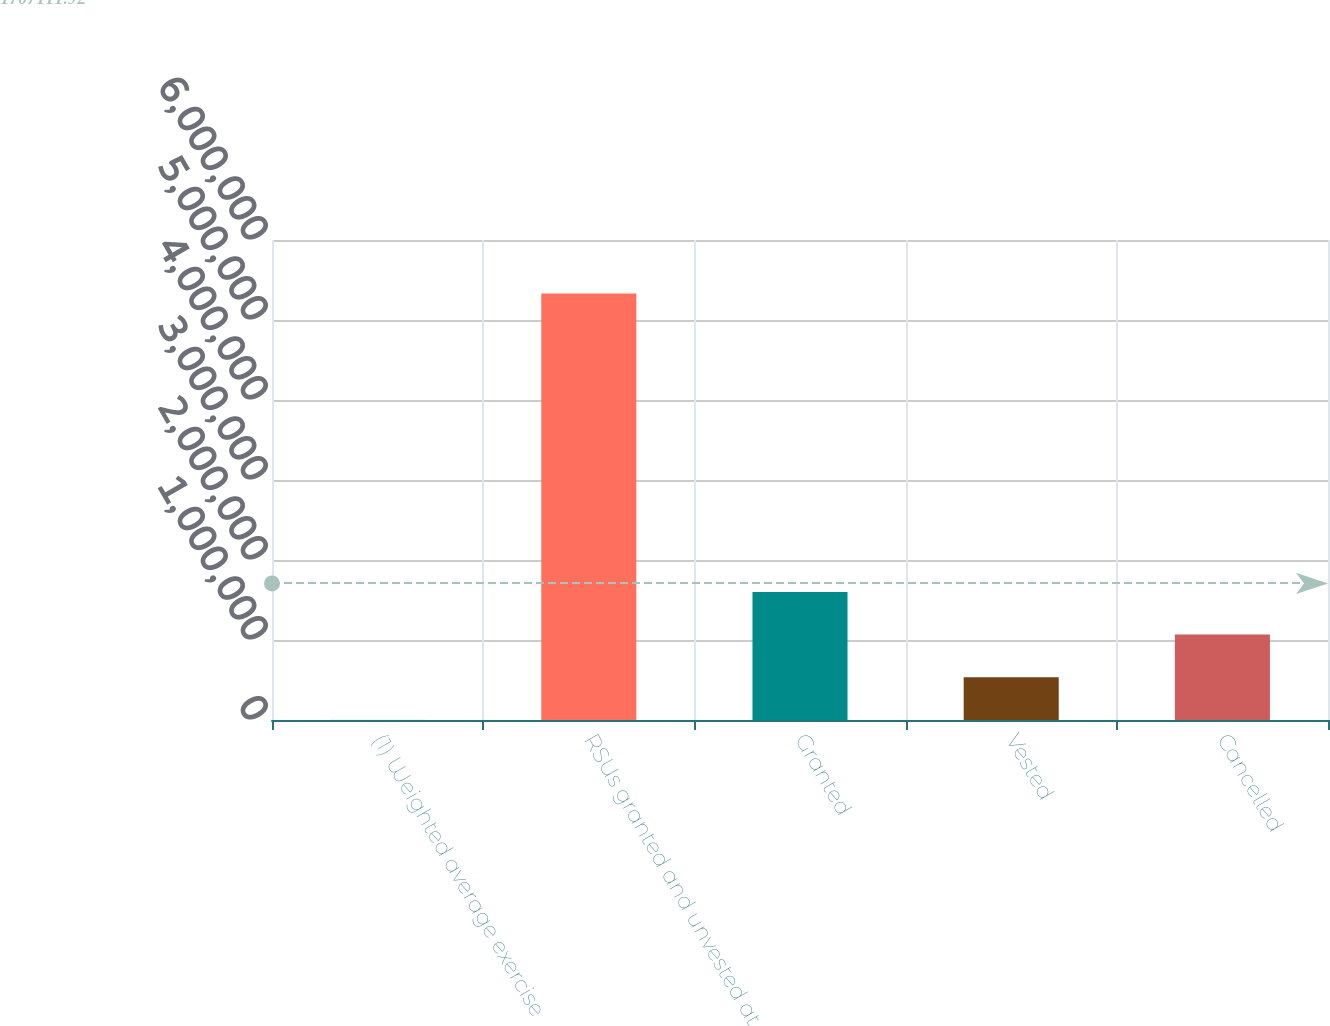Convert chart. <chart><loc_0><loc_0><loc_500><loc_500><bar_chart><fcel>(1) Weighted average exercise<fcel>RSUs granted and unvested at<fcel>Granted<fcel>Vested<fcel>Cancelled<nl><fcel>2014<fcel>5.33044e+06<fcel>1.60054e+06<fcel>534857<fcel>1.0677e+06<nl></chart> 